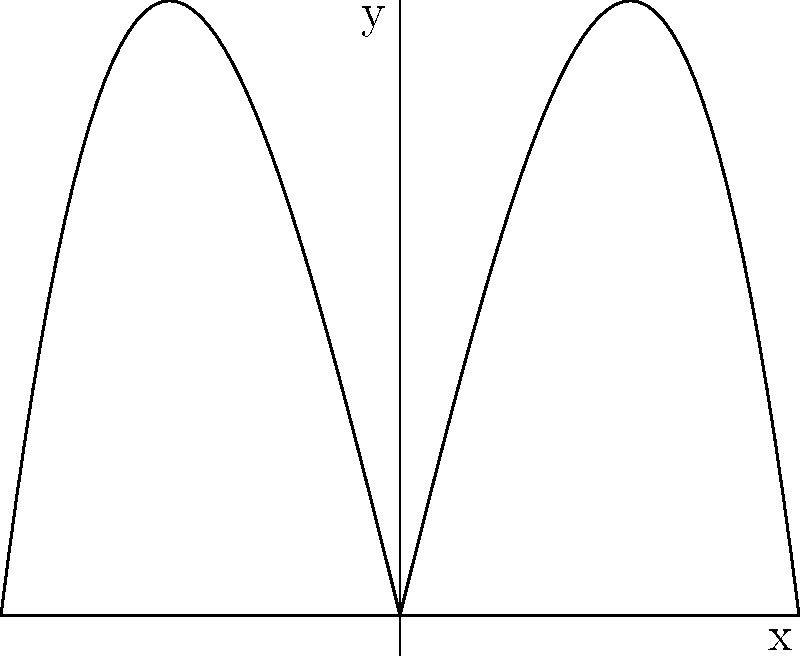The graph shows a polynomial function $f(x) = |x^3 - 4x|$ and its rotations to model the hexagonal symmetry of a snowflake. What is the minimum degree polynomial that can be used to create a similar shape with 6-fold rotational symmetry without using the absolute value function? To determine the minimum degree polynomial for a 6-fold rotational symmetry without using the absolute value function, we need to consider the following steps:

1. The given function $f(x) = |x^3 - 4x|$ uses the absolute value to create symmetry about the x-axis.

2. To achieve similar symmetry without the absolute value function, we need a polynomial that is always non-negative and touches the x-axis at multiple points.

3. The simplest such polynomial is of the form $y = x^2$.

4. However, $x^2$ alone doesn't provide the desired shape. We need lobes similar to the original function.

5. To create lobes, we can use a function of the form $y = (x^2 - a^2)^2$, where $a$ is a constant. This creates a shape with two lobes.

6. For 6-fold rotational symmetry, we need three pairs of lobes. This can be achieved by multiplying three such functions together:

   $y = (x^2 - a^2)^2 \cdot (x^2 - b^2)^2 \cdot (x^2 - c^2)^2$

7. Expanding this expression results in a polynomial of degree 12.

8. Therefore, the minimum degree polynomial that can create a shape with 6-fold rotational symmetry similar to the given function, without using the absolute value function, is 12.
Answer: 12 